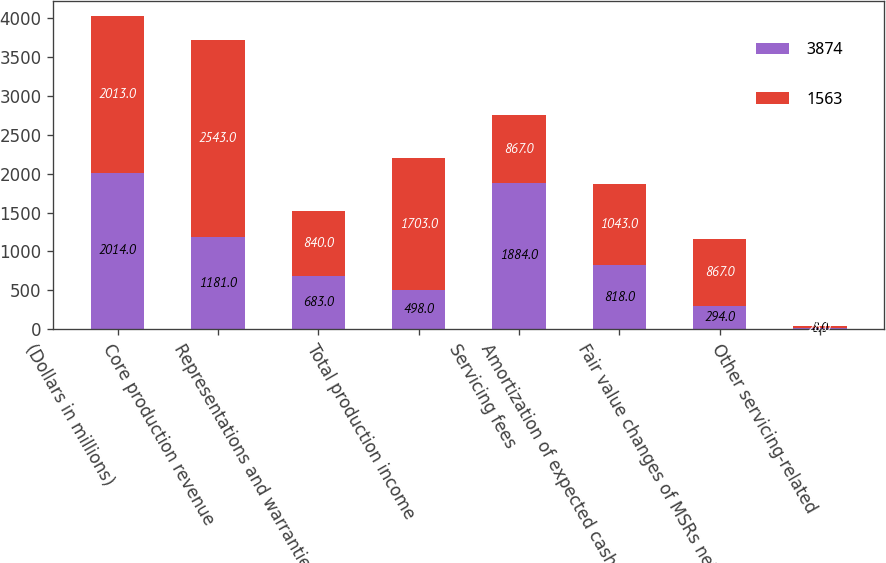Convert chart. <chart><loc_0><loc_0><loc_500><loc_500><stacked_bar_chart><ecel><fcel>(Dollars in millions)<fcel>Core production revenue<fcel>Representations and warranties<fcel>Total production income<fcel>Servicing fees<fcel>Amortization of expected cash<fcel>Fair value changes of MSRs net<fcel>Other servicing-related<nl><fcel>3874<fcel>2014<fcel>1181<fcel>683<fcel>498<fcel>1884<fcel>818<fcel>294<fcel>8<nl><fcel>1563<fcel>2013<fcel>2543<fcel>840<fcel>1703<fcel>867<fcel>1043<fcel>867<fcel>28<nl></chart> 